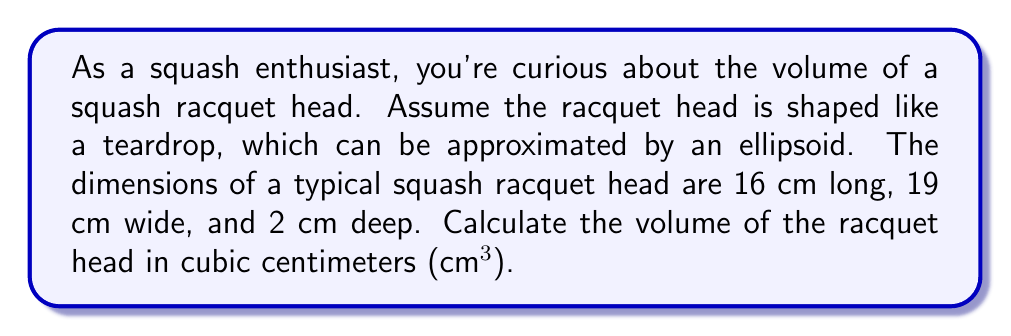Can you answer this question? To solve this problem, we'll use the formula for the volume of an ellipsoid:

$$V = \frac{4}{3}\pi abc$$

Where:
$a$, $b$, and $c$ are half the length, width, and depth of the ellipsoid respectively.

Given dimensions:
- Length = 16 cm, so $a = 8$ cm
- Width = 19 cm, so $b = 9.5$ cm
- Depth = 2 cm, so $c = 1$ cm

Let's substitute these values into the formula:

$$V = \frac{4}{3}\pi(8)(9.5)(1)$$

Now, let's calculate:

$$\begin{align}
V &= \frac{4}{3}\pi(76) \\
&= \frac{304\pi}{3} \\
&\approx 318.6 \text{ cm³}
\end{align}$$

Rounding to the nearest whole number, we get 319 cm³.

[asy]
import three;

size(200);
currentprojection=perspective(6,3,2);

draw(scale3(8,9.5,1)*unitsphere, surfacepen=material(diffusepen=gray(0.7), emissivepen=gray(0.2), specularpen=white));
draw(scale3(8,9.5,1)*path3(unitcircle), blue);
draw(scale3(8,9.5,0)*path3(unitcircle), blue+dashed);

label("16 cm", (9,0,0), E);
label("19 cm", (0,10.5,0), N);
label("2 cm", (0,0,1.5), W);
[/asy]
Answer: The volume of the squash racquet head is approximately 319 cm³. 